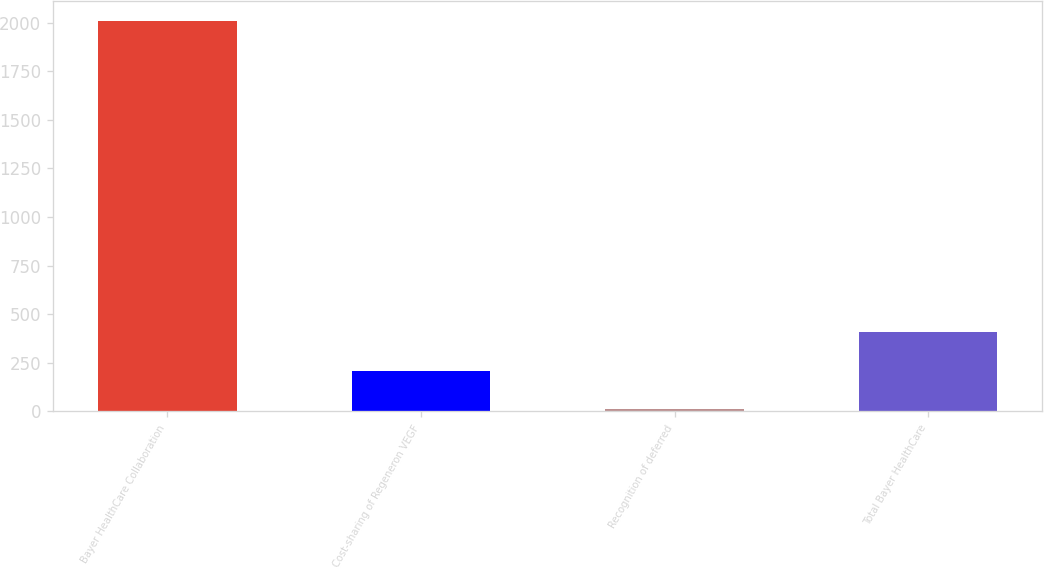<chart> <loc_0><loc_0><loc_500><loc_500><bar_chart><fcel>Bayer HealthCare Collaboration<fcel>Cost-sharing of Regeneron VEGF<fcel>Recognition of deferred<fcel>Total Bayer HealthCare<nl><fcel>2009<fcel>209.81<fcel>9.9<fcel>409.72<nl></chart> 